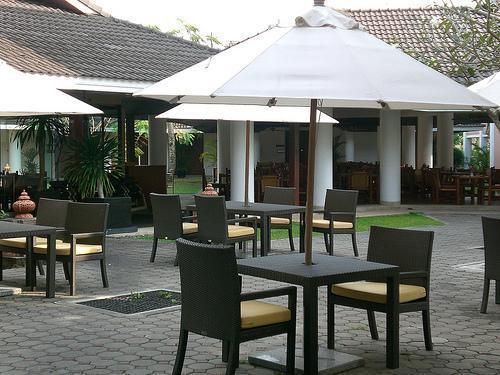How many chairs are at the front table?
Give a very brief answer. 2. How many chairs are at the table?
Give a very brief answer. 2. How many trees are there?
Give a very brief answer. 2. How many tables are there?
Give a very brief answer. 3. How many chairs are with the smallest table with an umbrella?
Give a very brief answer. 2. How many chairs are at the table in the foreground?
Give a very brief answer. 2. How many chairs are at the table in the background?
Give a very brief answer. 4. 